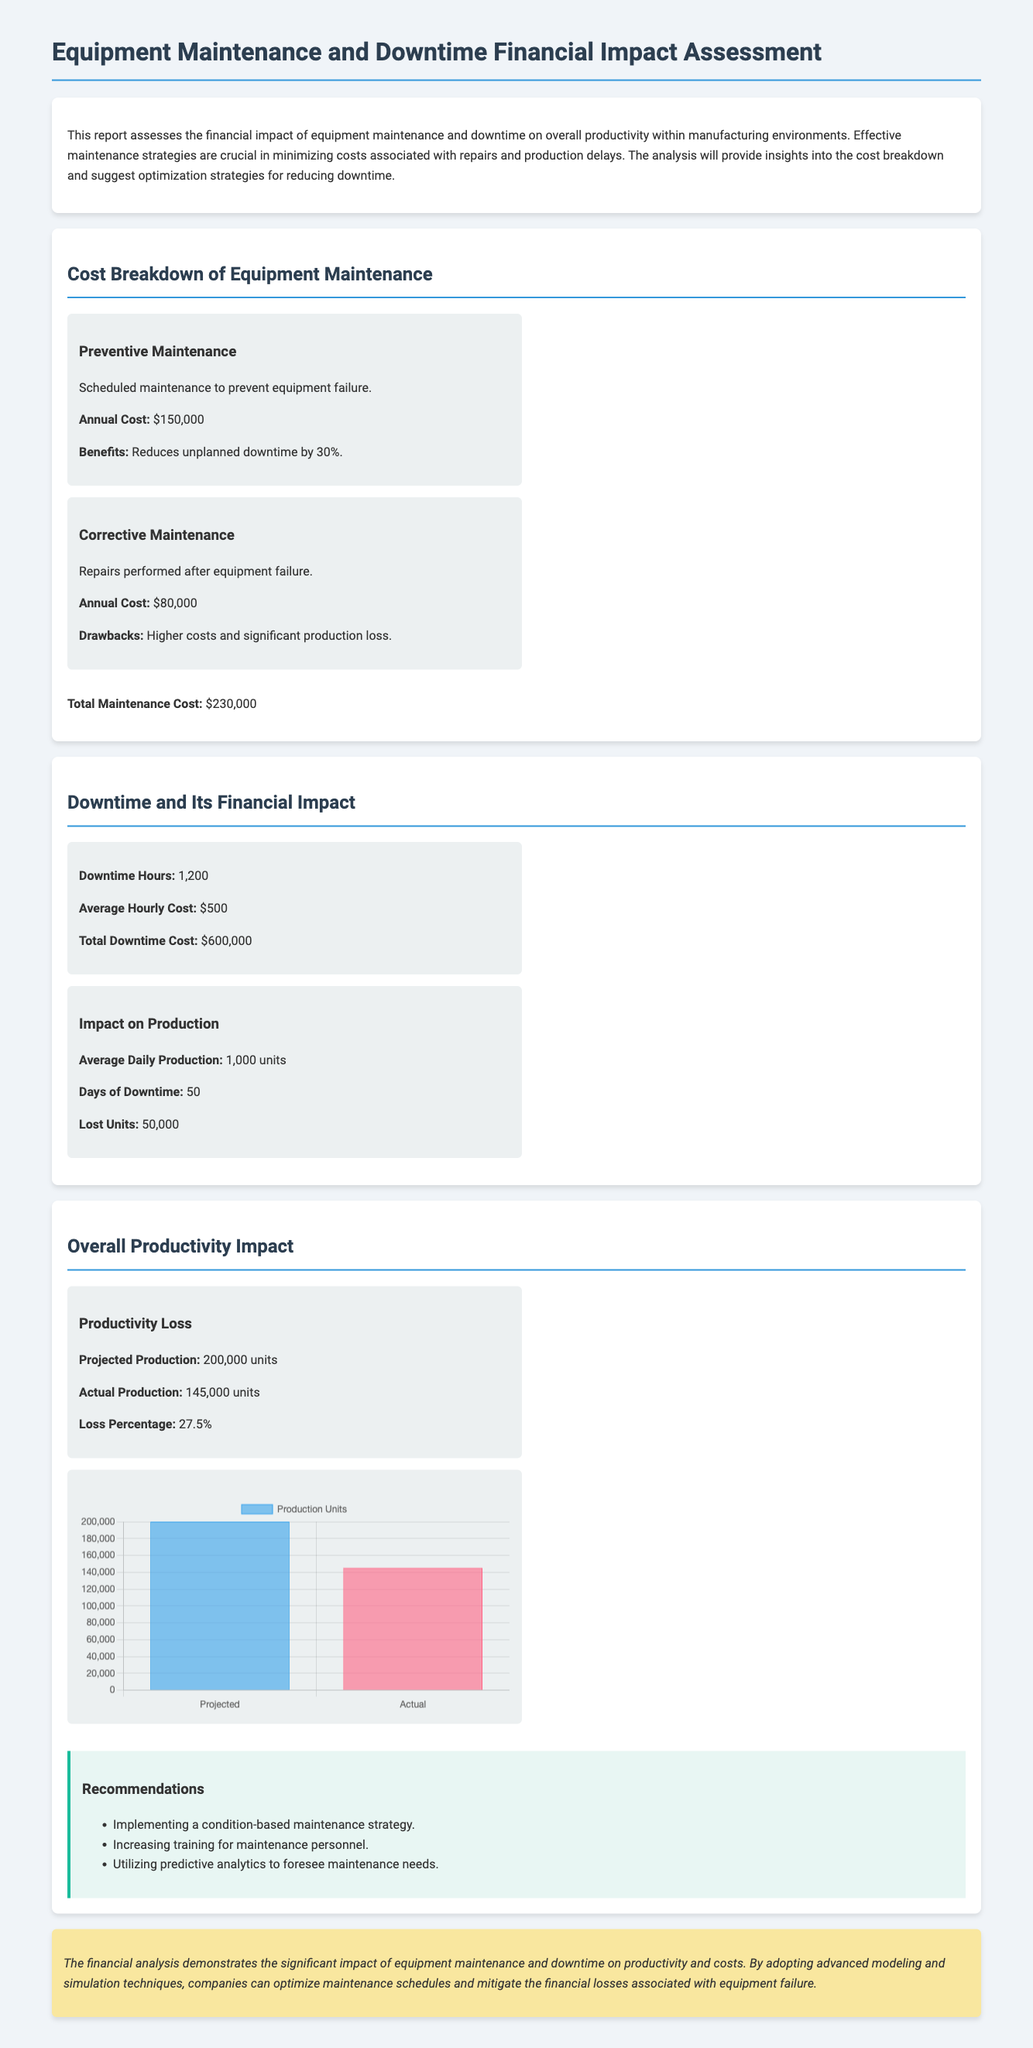What is the annual cost of preventive maintenance? The annual cost of preventive maintenance is specifically stated in the document as $150,000.
Answer: $150,000 What percentage reduction in unplanned downtime is achieved through preventive maintenance? The document states that preventive maintenance reduces unplanned downtime by 30%.
Answer: 30% What is the total downtime cost? The total downtime cost is shown in the document as the product of downtime hours and the average hourly cost, which is 1,200 hours multiplied by $500, equaling $600,000.
Answer: $600,000 How many units were lost due to downtime? The document explicitly mentions that the lost units due to downtime are 50,000.
Answer: 50,000 What is the loss percentage in actual production? The document indicates the loss percentage in actual production is calculated as 27.5%.
Answer: 27.5% What is the projected production amount? According to the document, the projected production is stated as 200,000 units.
Answer: 200,000 units What premium does corrective maintenance incur compared to preventive maintenance? Corrective maintenance is noted for having higher costs compared to preventive maintenance, specifically $80,000 for corrective compared to $150,000 for preventive, thus indicating higher costs.
Answer: Higher costs What strategy is recommended to optimize maintenance? The document recommends implementing a condition-based maintenance strategy to optimize maintenance efforts.
Answer: Condition-based maintenance strategy How many days of downtime occurred? The report specifically quantifies the days of downtime as 50.
Answer: 50 days 